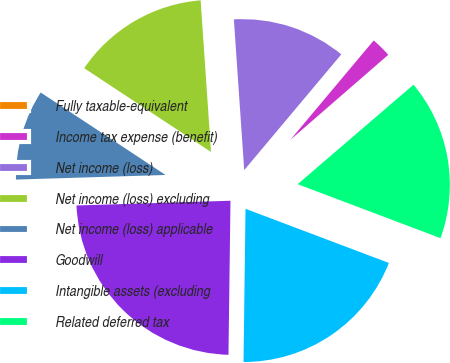Convert chart to OTSL. <chart><loc_0><loc_0><loc_500><loc_500><pie_chart><fcel>Fully taxable-equivalent<fcel>Income tax expense (benefit)<fcel>Net income (loss)<fcel>Net income (loss) excluding<fcel>Net income (loss) applicable<fcel>Goodwill<fcel>Intangible assets (excluding<fcel>Related deferred tax<nl><fcel>0.09%<fcel>2.51%<fcel>12.2%<fcel>14.62%<fcel>9.78%<fcel>24.31%<fcel>19.46%<fcel>17.04%<nl></chart> 